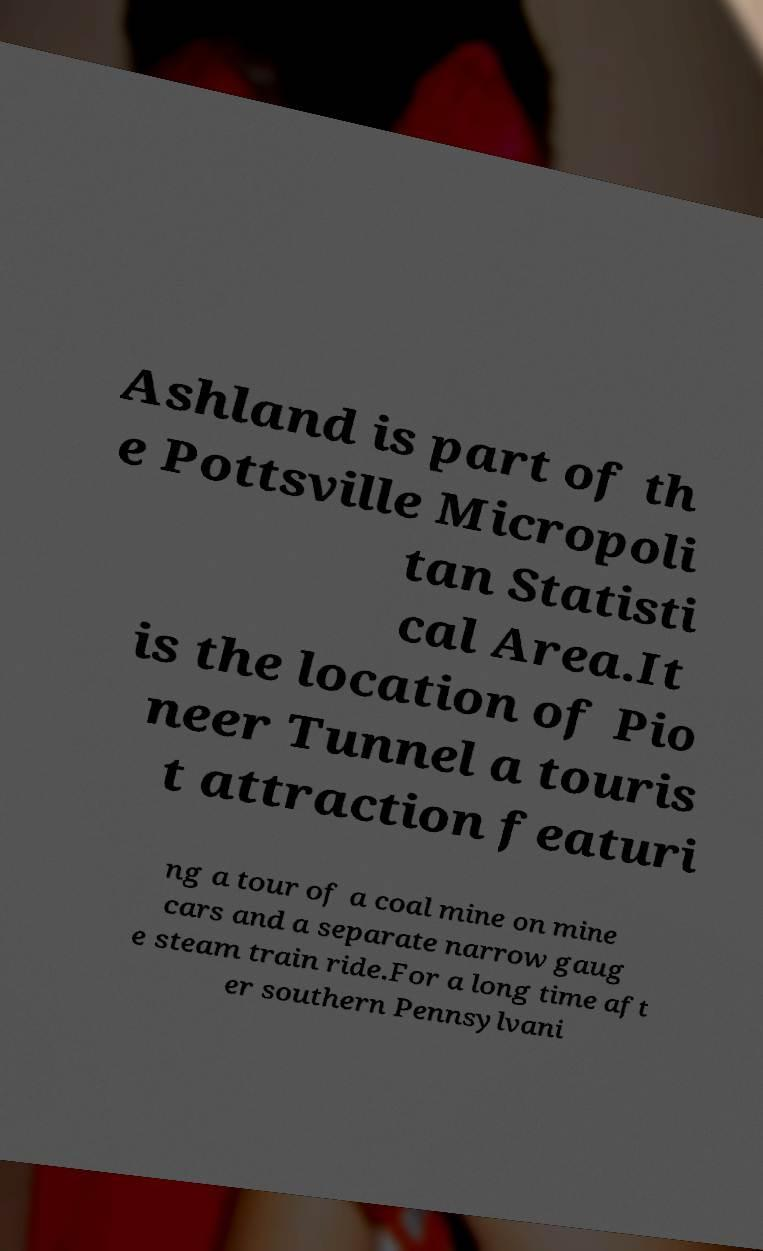What messages or text are displayed in this image? I need them in a readable, typed format. Ashland is part of th e Pottsville Micropoli tan Statisti cal Area.It is the location of Pio neer Tunnel a touris t attraction featuri ng a tour of a coal mine on mine cars and a separate narrow gaug e steam train ride.For a long time aft er southern Pennsylvani 